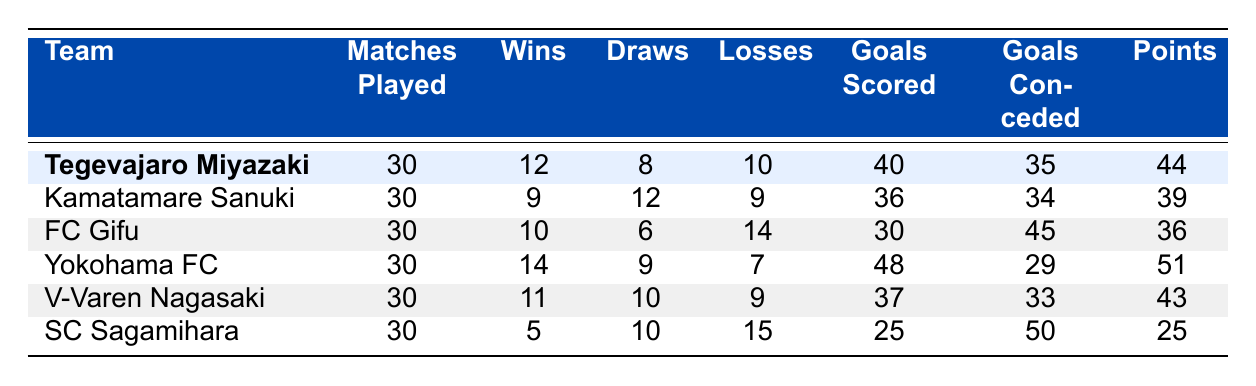What is the total number of wins for Tegevajaro Miyazaki? The table shows that Tegevajaro Miyazaki has a total of 12 wins.
Answer: 12 Which team has the highest number of goals scored? Yokohama FC has scored the highest number of goals with a total of 48, as indicated in the goals scored column.
Answer: Yokohama FC How many points does Kamatamare Sanuki have? According to the table, Kamatamare Sanuki has a total of 39 points.
Answer: 39 What is the average number of goals conceded by all teams? To find the average, we add the goals conceded by all teams: 35 + 34 + 45 + 29 + 33 + 50 = 226. Then, divide by the number of teams, which is 6. So, 226/6 = approximately 37.67.
Answer: 37.67 Is it true that FC Gifu has more wins than SC Sagamihara? FC Gifu has 10 wins, while SC Sagamihara has only 5 wins, making the statement true.
Answer: Yes What is the difference in points between Tegevajaro Miyazaki and V-Varen Nagasaki? Tegevajaro Miyazaki has 44 points and V-Varen Nagasaki has 43 points, so the difference is 44 - 43 = 1 point.
Answer: 1 How many teams have more points than Tegevajaro Miyazaki? Yokohama FC has 51 points, and thus has more points than Tegevajaro Miyazaki, while the others do not exceed 44 points. Therefore, only 1 team has more points.
Answer: 1 What is the total number of matches played by all teams combined? Adding the matches played: 30 (Tegevajaro Miyazaki) + 30 + 30 + 30 + 30 + 30 = 180. Therefore, the total number of matches played is 180.
Answer: 180 Which team has the same number of draws as Kamatamare Sanuki? Kamatamare Sanuki has 12 draws, while V-Varen Nagasaki also has 10 draws, but no other team matches them. Therefore, there are no teams that have the same number of draws.
Answer: No team 